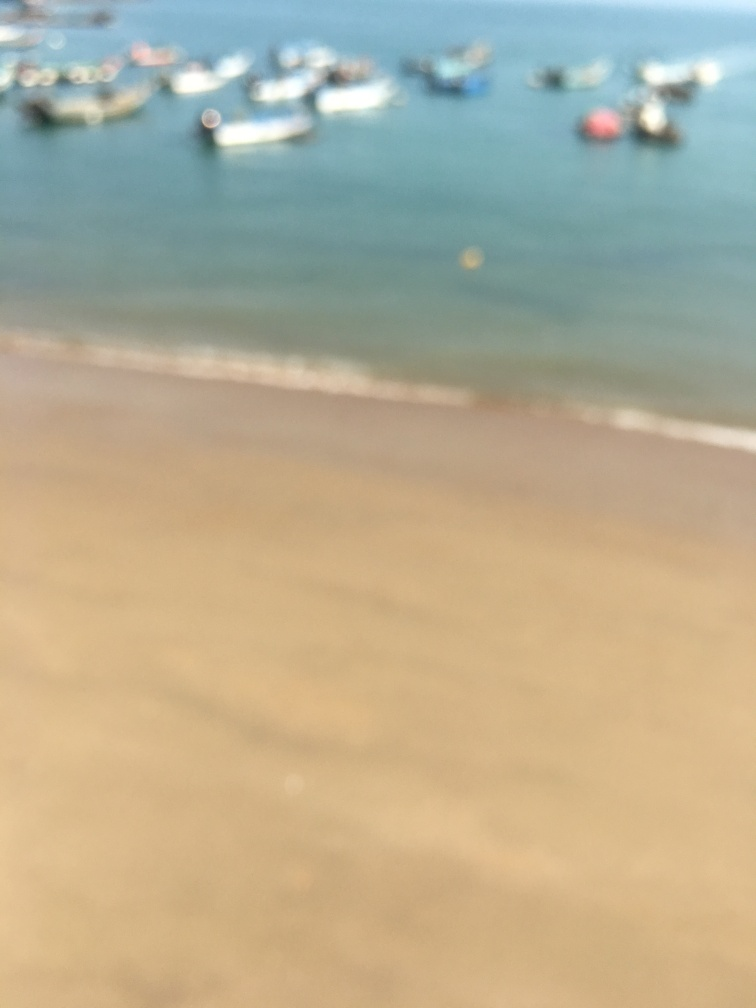Considering the blurriness of the photo, is there any indication of the time of day or weather conditions in this scene? While specific details are obscured, the lighting appears soft and diffused, possibly indicating that this image was taken on a sunny day, possibly in the morning or late afternoon when the sunlight is not too harsh. The absence of harsh shadows or overly bright spots suggests a mild weather condition. 